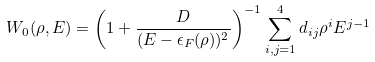Convert formula to latex. <formula><loc_0><loc_0><loc_500><loc_500>W _ { 0 } ( \rho , E ) = \left ( 1 + { \frac { D } { { ( E - \epsilon _ { F } ( \rho ) ) ^ { 2 } } } } \right ) ^ { - 1 } \sum _ { i , j = 1 } ^ { 4 } d _ { i j } \rho ^ { i } E ^ { j - 1 }</formula> 